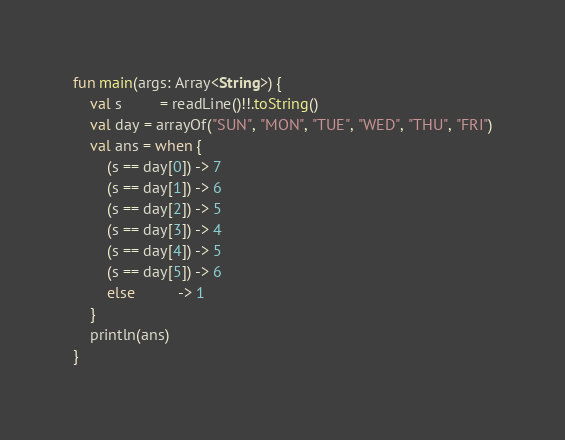<code> <loc_0><loc_0><loc_500><loc_500><_Kotlin_>fun main(args: Array<String>) {
    val s         = readLine()!!.toString()
    val day = arrayOf("SUN", "MON", "TUE", "WED", "THU", "FRI")
    val ans = when {
        (s == day[0]) -> 7
        (s == day[1]) -> 6
        (s == day[2]) -> 5
        (s == day[3]) -> 4
        (s == day[4]) -> 5
        (s == day[5]) -> 6
        else          -> 1
    }
    println(ans)
}</code> 